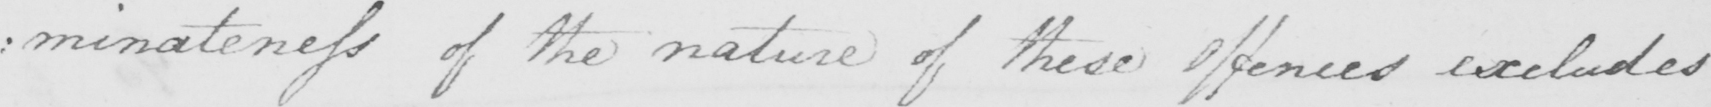Can you read and transcribe this handwriting? :minateness of the nature of these offences excludes 